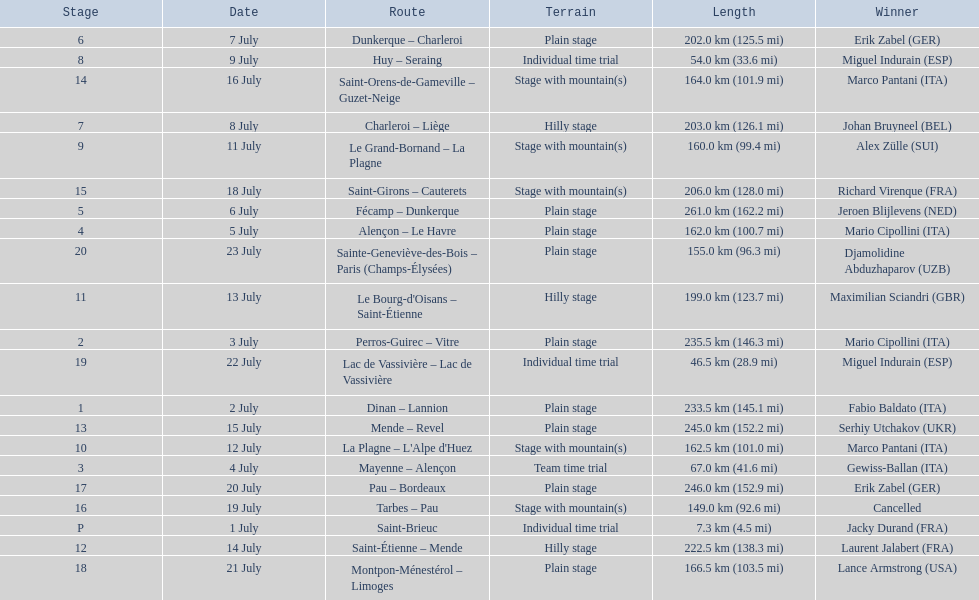How many routes have below 100 km total? 4. 